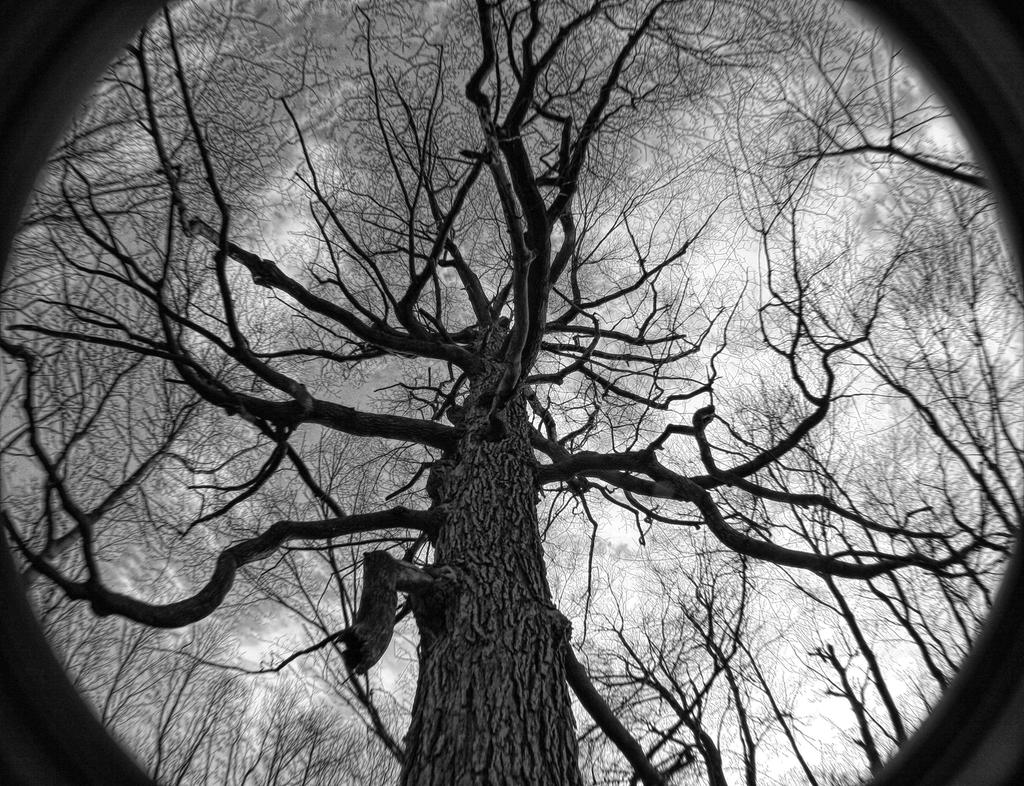What is the main subject of the image? The main subject of the image is a dry tree at the center of the image. Are there any other trees in the image? Yes, there are other dry trees surrounding the central tree. What can be seen in the background of the image? The sky is visible at the top of the image. How is the glue being used in the image? There is no glue present in the image. Can you see any fingers in the image? There are no fingers visible in the image. 